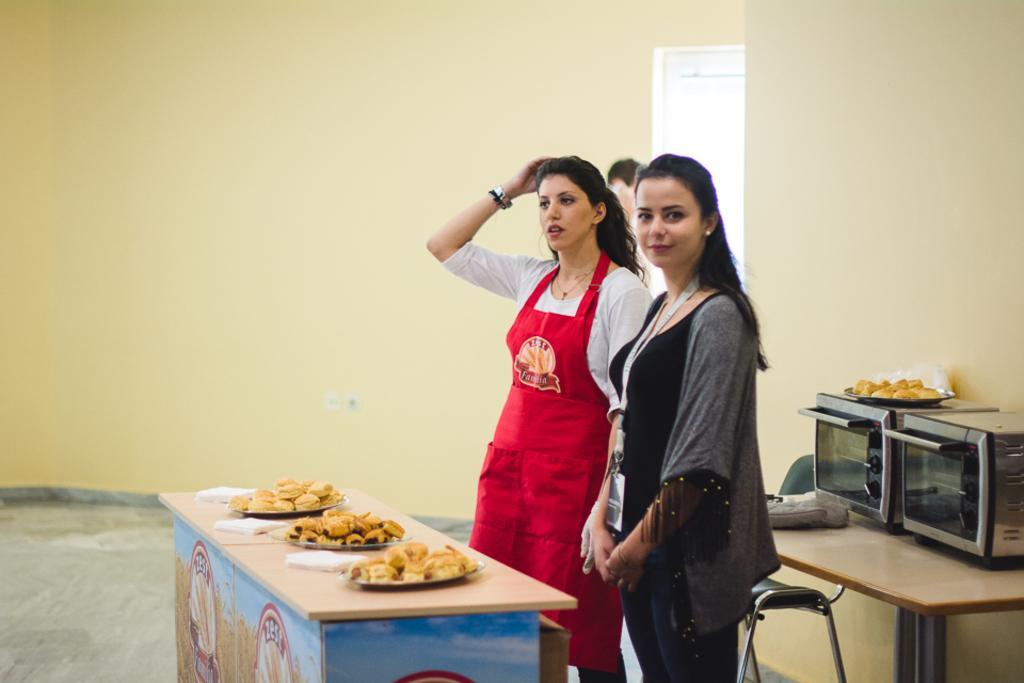How would you summarize this image in a sentence or two? In this image there are 2 women standing near the table and in the table we have food in the plates and in the back ground we have micro wave oven in the table and a chair , and another group of people standing near the door. 